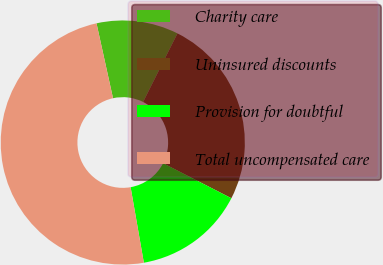Convert chart to OTSL. <chart><loc_0><loc_0><loc_500><loc_500><pie_chart><fcel>Charity care<fcel>Uninsured discounts<fcel>Provision for doubtful<fcel>Total uncompensated care<nl><fcel>10.85%<fcel>25.15%<fcel>14.69%<fcel>49.31%<nl></chart> 